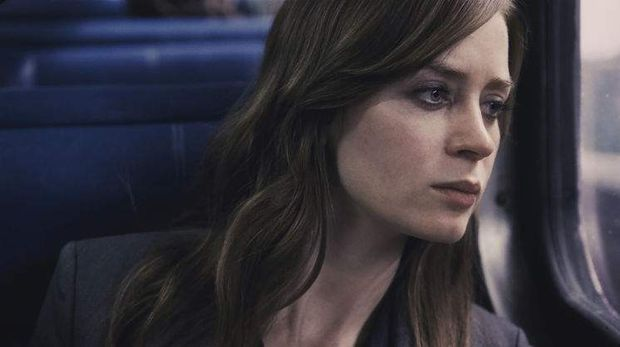How does the lighting contribute to the mood of this image? The subdued lighting in the image, combined with the overcast sky visible through the train window, complements her contemplative mood. It casts soft shadows on her face, enhancing her thoughtful expression and adding depth to the visual narrative of introspection and uncertainty. 